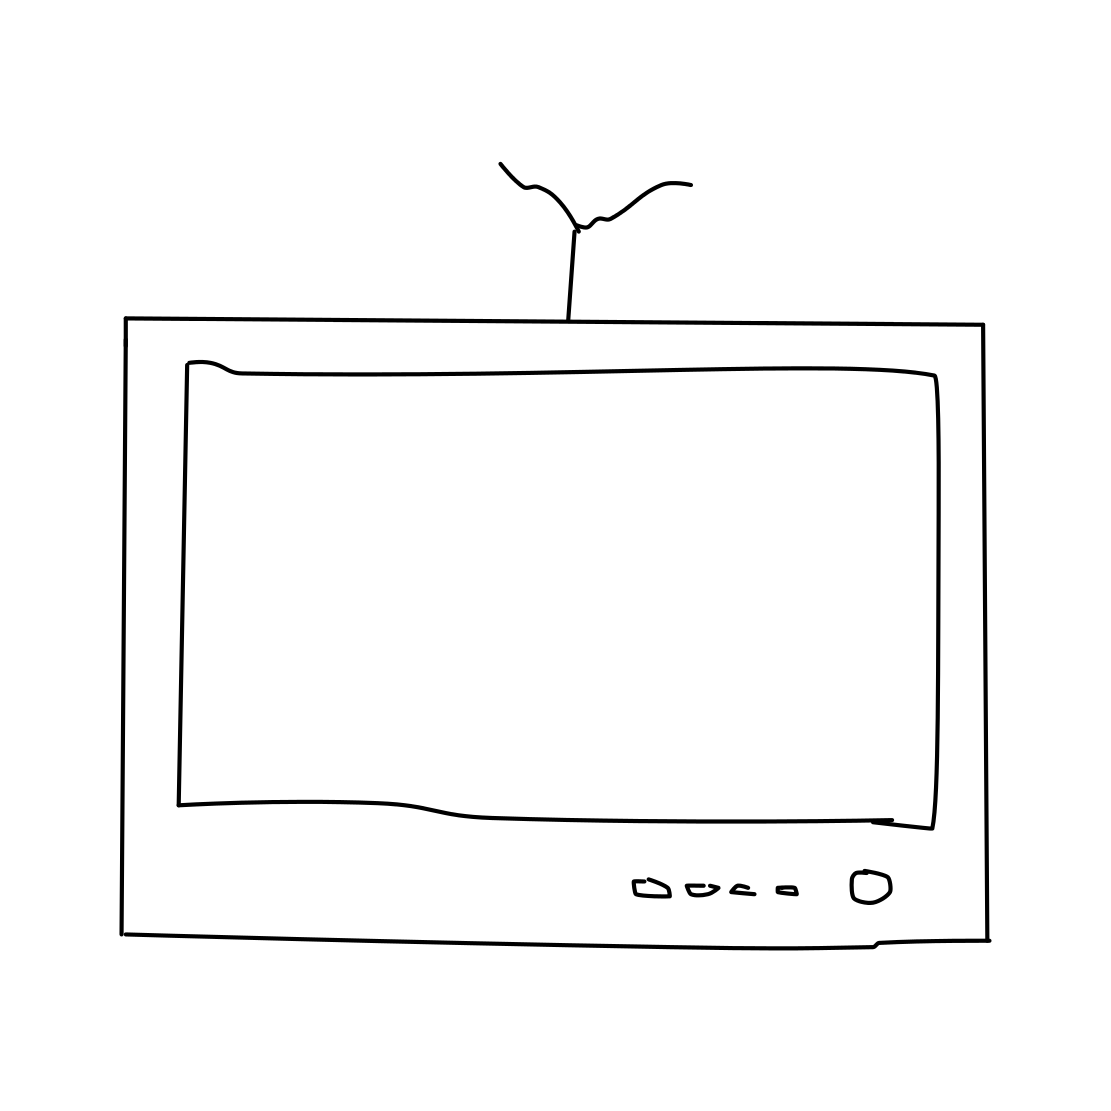What era does this TV seem to represent? The TV in the image has a classic feel, likely representing an older model from an era before flat-screen and smart TVs became prevalent. The presence of an antenna suggests it's from a time when televisions received analog signals, which could date it back to the late 20th century. 